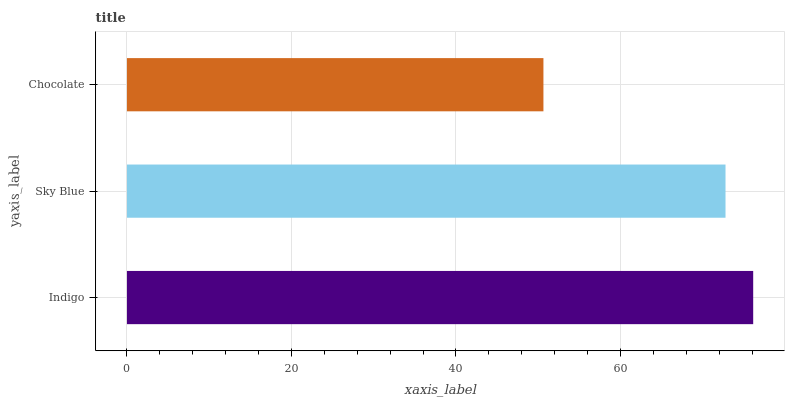Is Chocolate the minimum?
Answer yes or no. Yes. Is Indigo the maximum?
Answer yes or no. Yes. Is Sky Blue the minimum?
Answer yes or no. No. Is Sky Blue the maximum?
Answer yes or no. No. Is Indigo greater than Sky Blue?
Answer yes or no. Yes. Is Sky Blue less than Indigo?
Answer yes or no. Yes. Is Sky Blue greater than Indigo?
Answer yes or no. No. Is Indigo less than Sky Blue?
Answer yes or no. No. Is Sky Blue the high median?
Answer yes or no. Yes. Is Sky Blue the low median?
Answer yes or no. Yes. Is Chocolate the high median?
Answer yes or no. No. Is Indigo the low median?
Answer yes or no. No. 